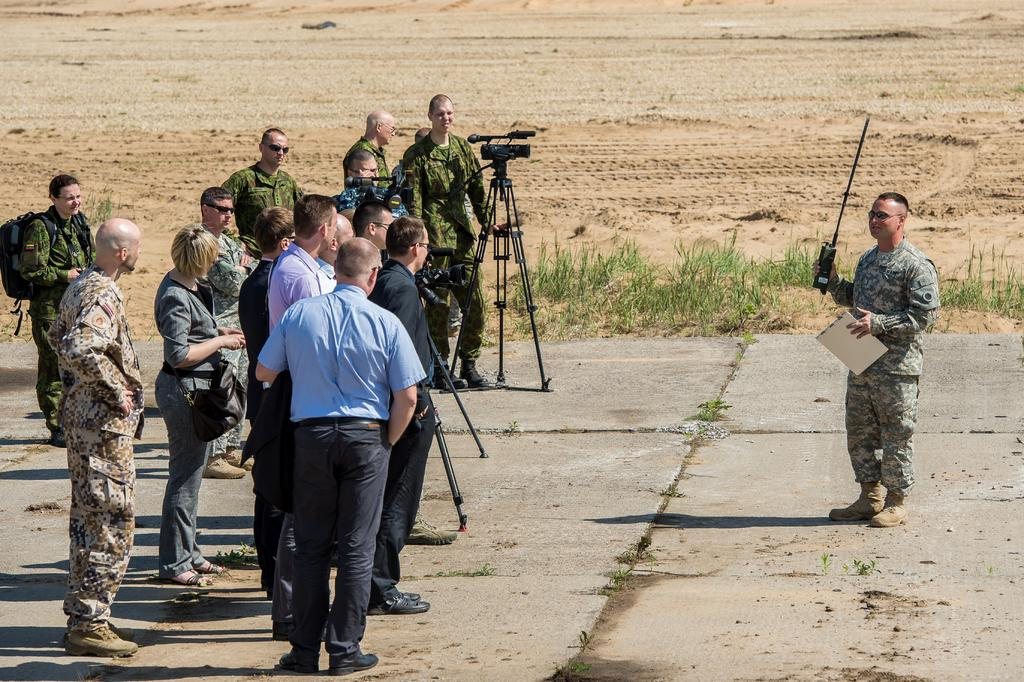What are the persons in the image doing? The persons in the image are standing on the ground and holding a phone and a pad. What can be seen in the image besides the persons? There is a stand with a camera in the image. What type of surface is the persons standing on? The ground is visible in the image, and the persons are standing on it. What kind of vegetation is present in the image? There is grass in the image. What is the rate of the cactus's growth in the image? There is no cactus present in the image, so it is not possible to determine its growth rate. 